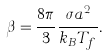Convert formula to latex. <formula><loc_0><loc_0><loc_500><loc_500>\beta = \frac { 8 \pi } { 3 } \frac { \sigma a ^ { 2 } } { k _ { B } T _ { f } } .</formula> 